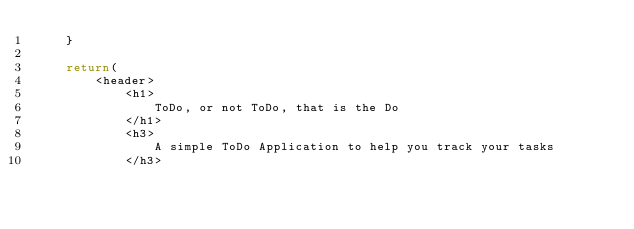<code> <loc_0><loc_0><loc_500><loc_500><_JavaScript_>    }

    return(
        <header>
            <h1>
                ToDo, or not ToDo, that is the Do
            </h1>
            <h3>
                A simple ToDo Application to help you track your tasks
            </h3></code> 